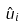Convert formula to latex. <formula><loc_0><loc_0><loc_500><loc_500>\hat { u } _ { i }</formula> 